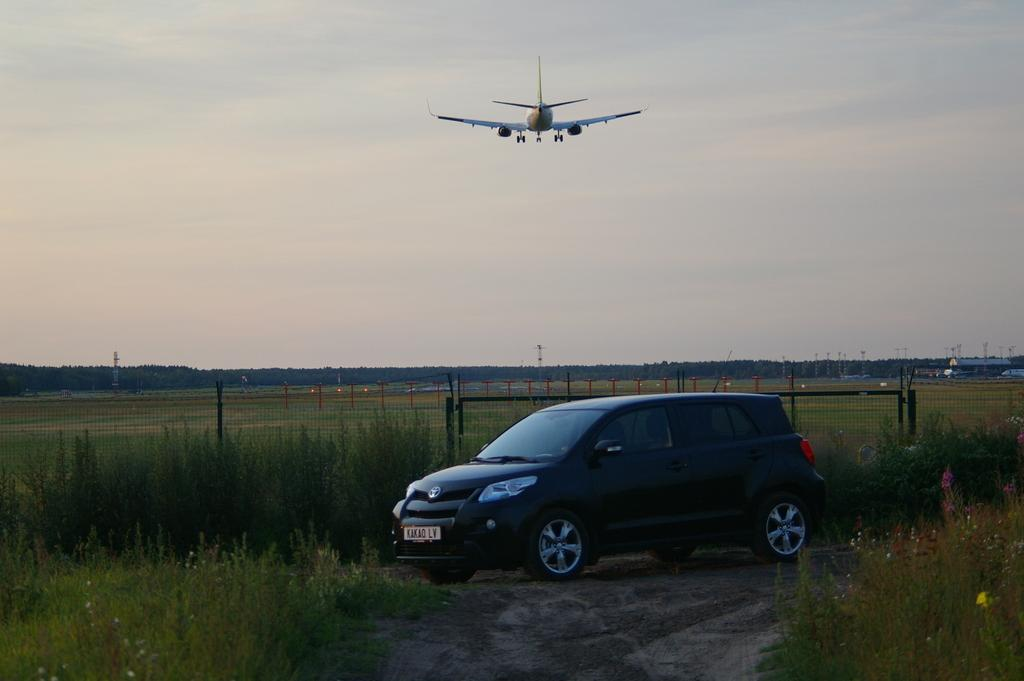What is the main subject in the center of the image? There is a car in the center of the image. What type of terrain is visible at the bottom of the image? There is grass at the bottom of the image. What type of barrier can be seen in the image? There is a fence visible in the image. What is flying in the sky at the top of the image? An aeroplane is flying in the sky at the top of the image. What color is the ear of the person sitting in the car? There is no person sitting in the car, and therefore no ear is visible in the image. 